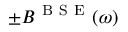Convert formula to latex. <formula><loc_0><loc_0><loc_500><loc_500>\pm B ^ { B S E } ( \omega )</formula> 